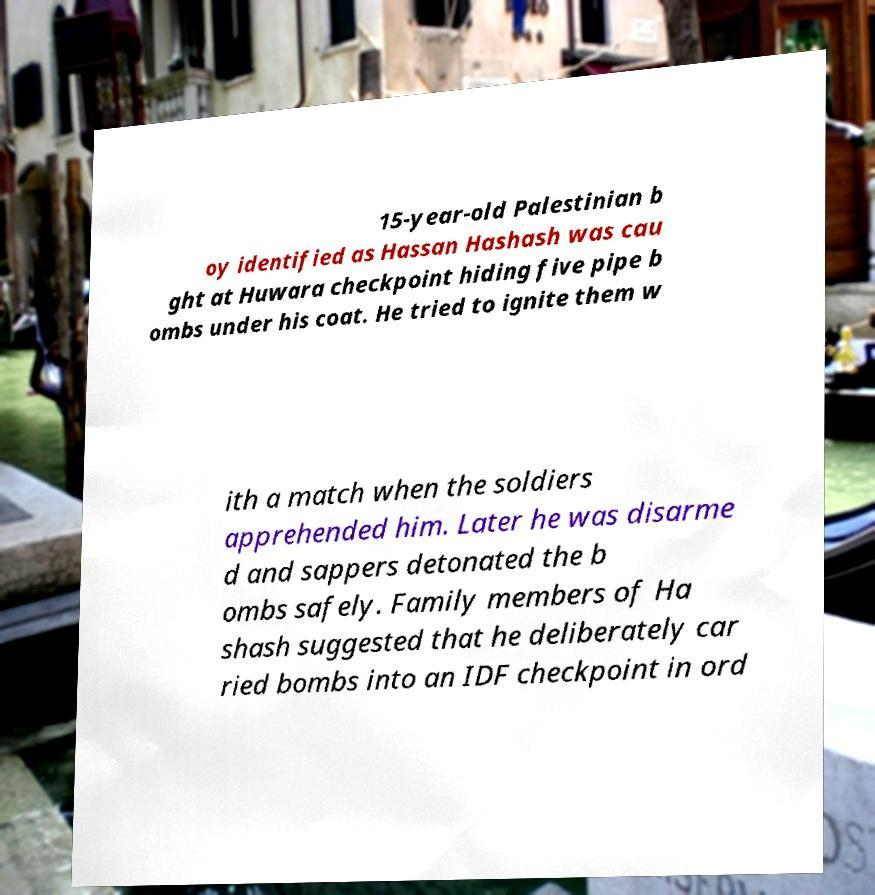There's text embedded in this image that I need extracted. Can you transcribe it verbatim? 15-year-old Palestinian b oy identified as Hassan Hashash was cau ght at Huwara checkpoint hiding five pipe b ombs under his coat. He tried to ignite them w ith a match when the soldiers apprehended him. Later he was disarme d and sappers detonated the b ombs safely. Family members of Ha shash suggested that he deliberately car ried bombs into an IDF checkpoint in ord 